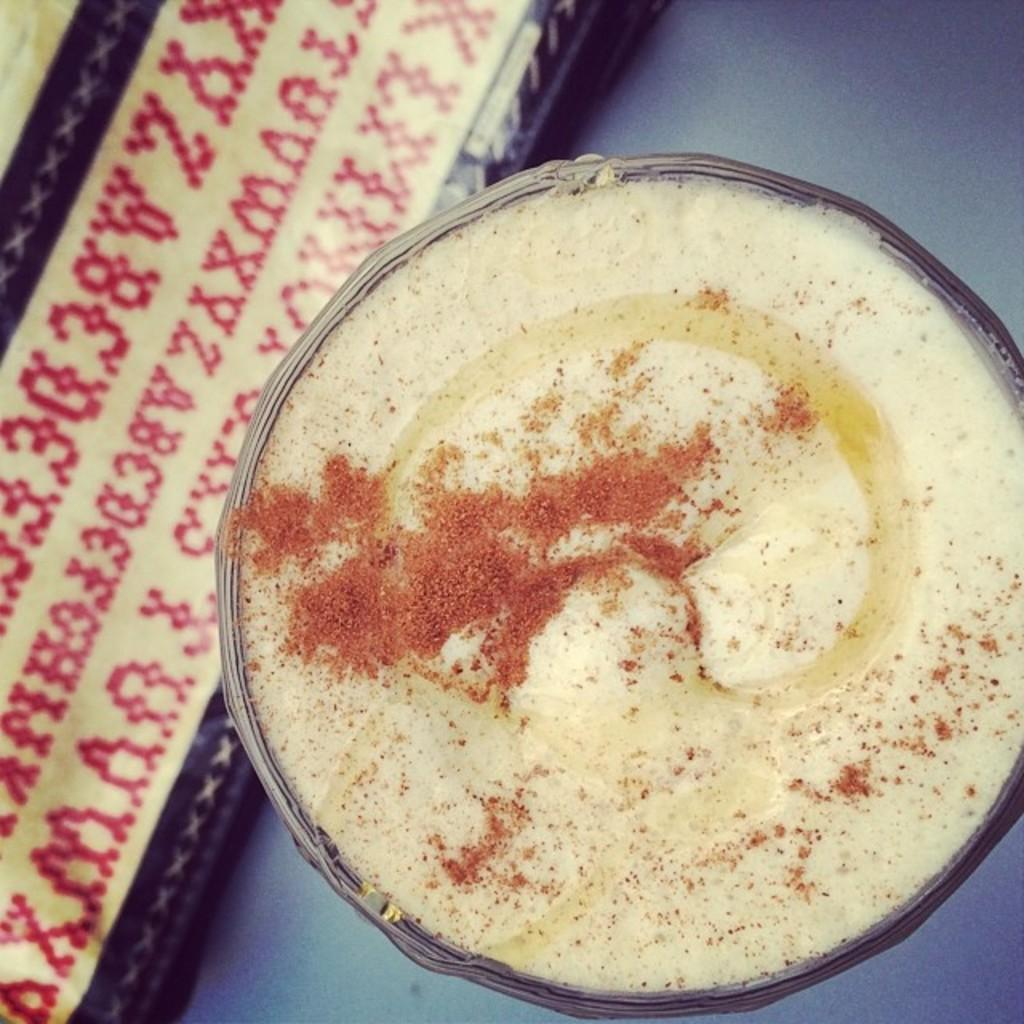What is in the bowl that is visible in the image? There is food in a bowl in the image. What else can be seen on the cloth in the image? There is text on a cloth in the image. Where is the table located in the image? There appears to be a table at the bottom of the image. What type of fiction is being read from the wheel in the image? There is no wheel or fiction present in the image. How does the acoustics of the room affect the text on the cloth in the image? The acoustics of the room do not affect the text on the cloth in the image, as it is a static image and not a real-life scenario. 